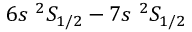<formula> <loc_0><loc_0><loc_500><loc_500>6 s ^ { 2 } S _ { 1 / 2 } - 7 s ^ { 2 } S _ { 1 / 2 }</formula> 